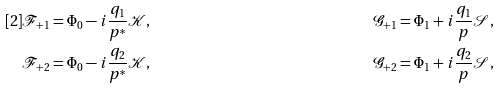<formula> <loc_0><loc_0><loc_500><loc_500>[ 2 ] & \mathcal { F } _ { + 1 } = \Phi _ { 0 } - i \frac { q _ { 1 } } { p ^ { \ast } } \mathcal { K } , \quad & \mathcal { G } _ { + 1 } = \Phi _ { 1 } + i \frac { q _ { 1 } } { p } \mathcal { S } , \\ & \mathcal { F } _ { + 2 } = \Phi _ { 0 } - i \frac { q _ { 2 } } { p ^ { \ast } } \mathcal { K } , \quad & \mathcal { G } _ { + 2 } = \Phi _ { 1 } + i \frac { q _ { 2 } } { p } \mathcal { S } ,</formula> 